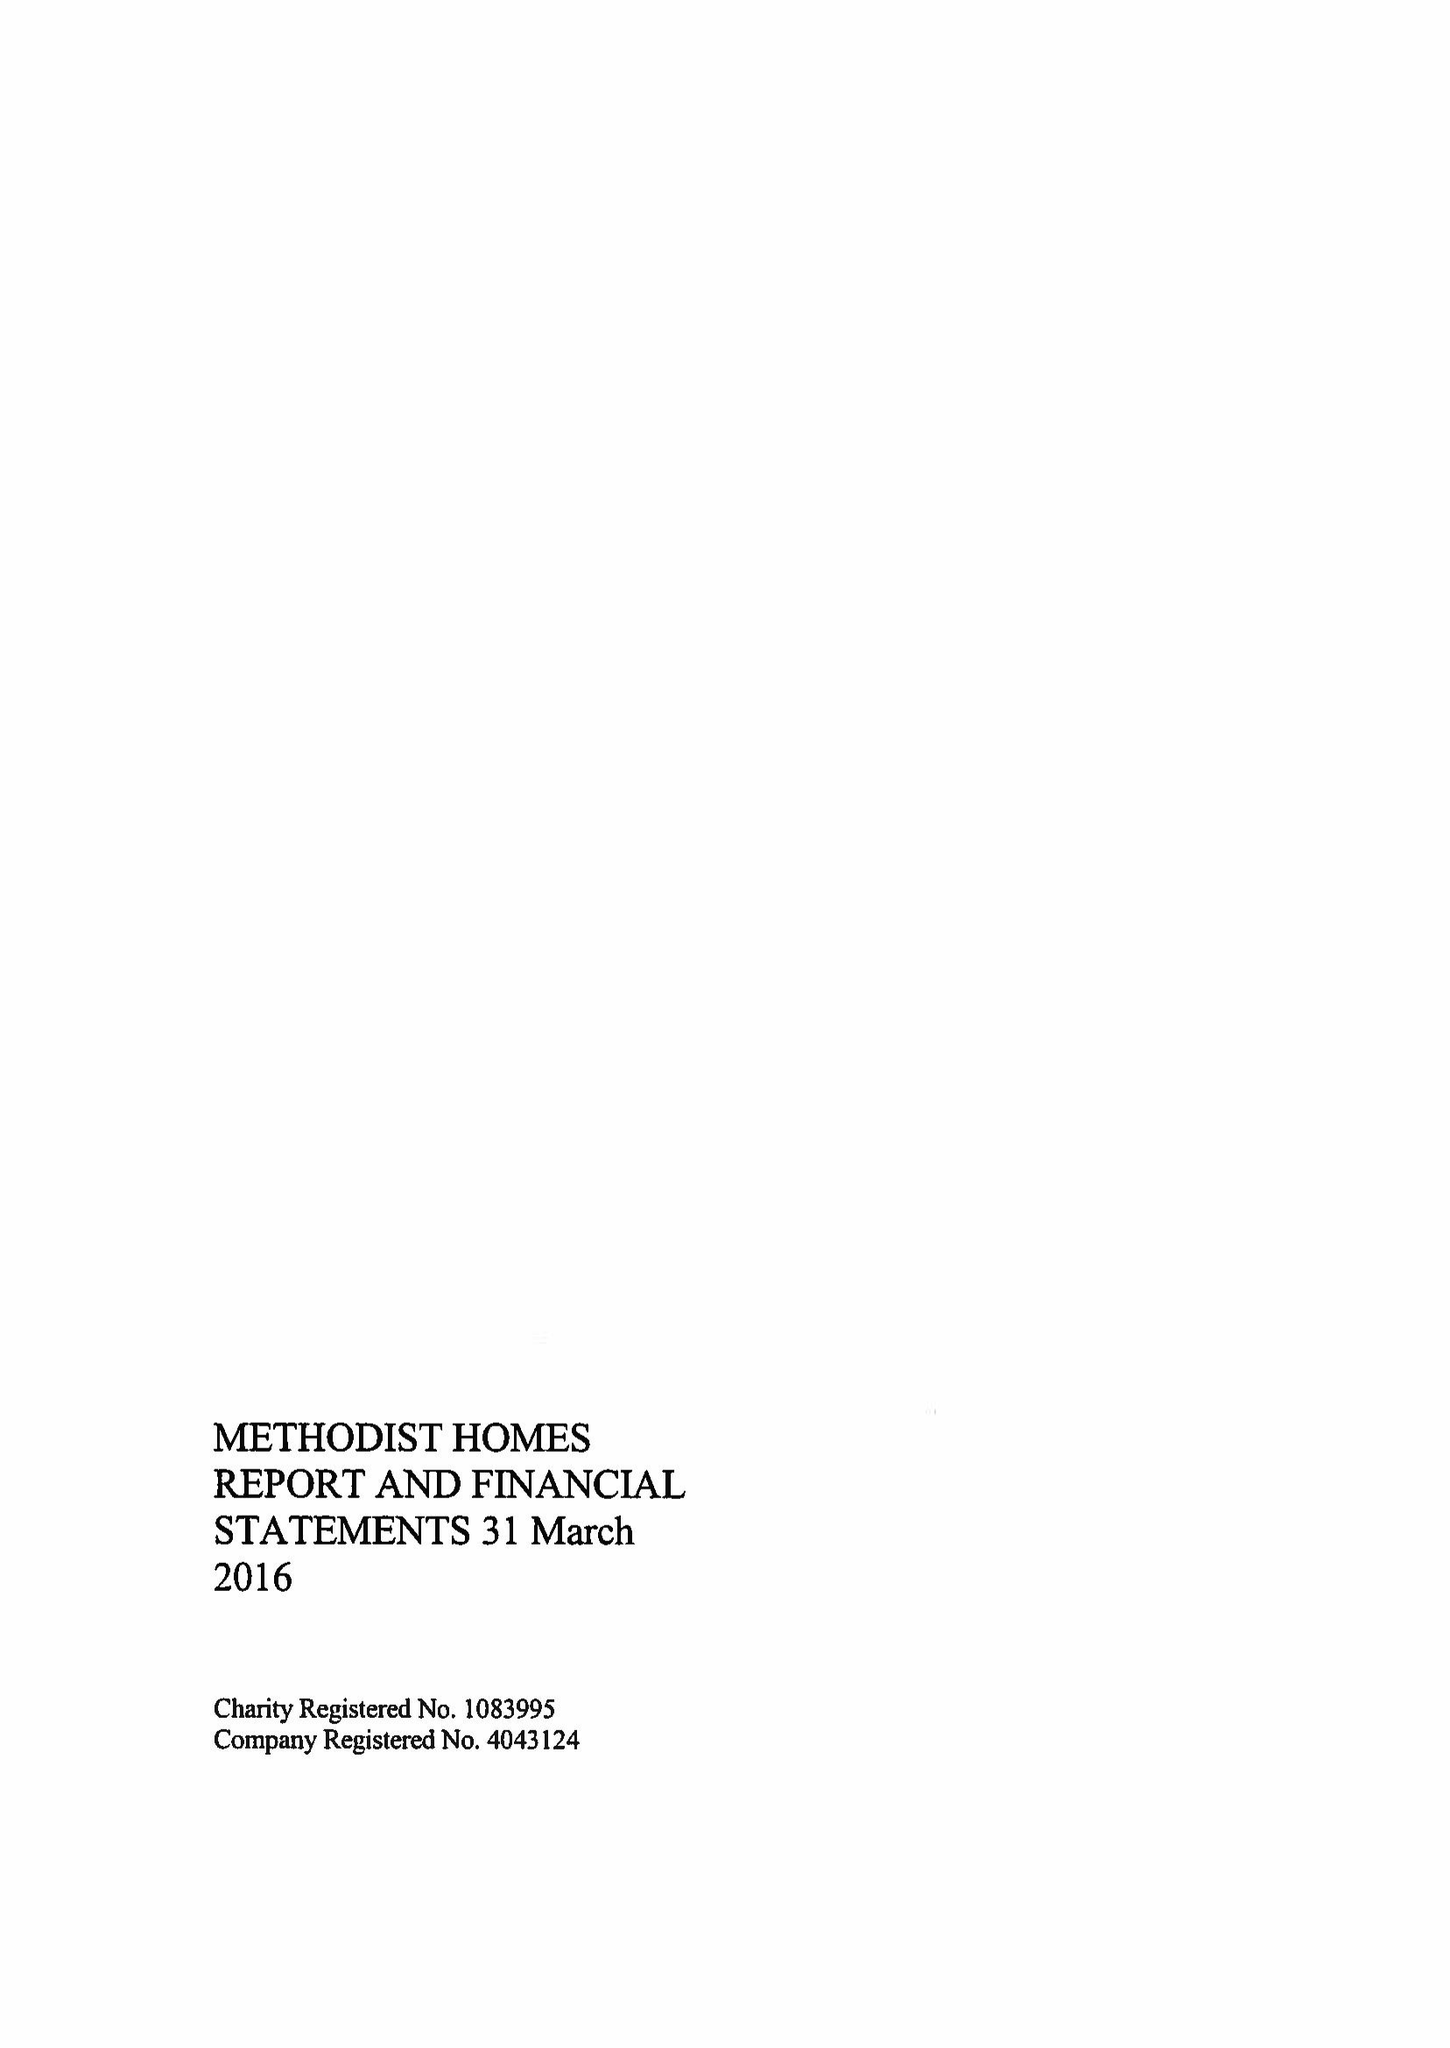What is the value for the address__street_line?
Answer the question using a single word or phrase. STUART STREET 